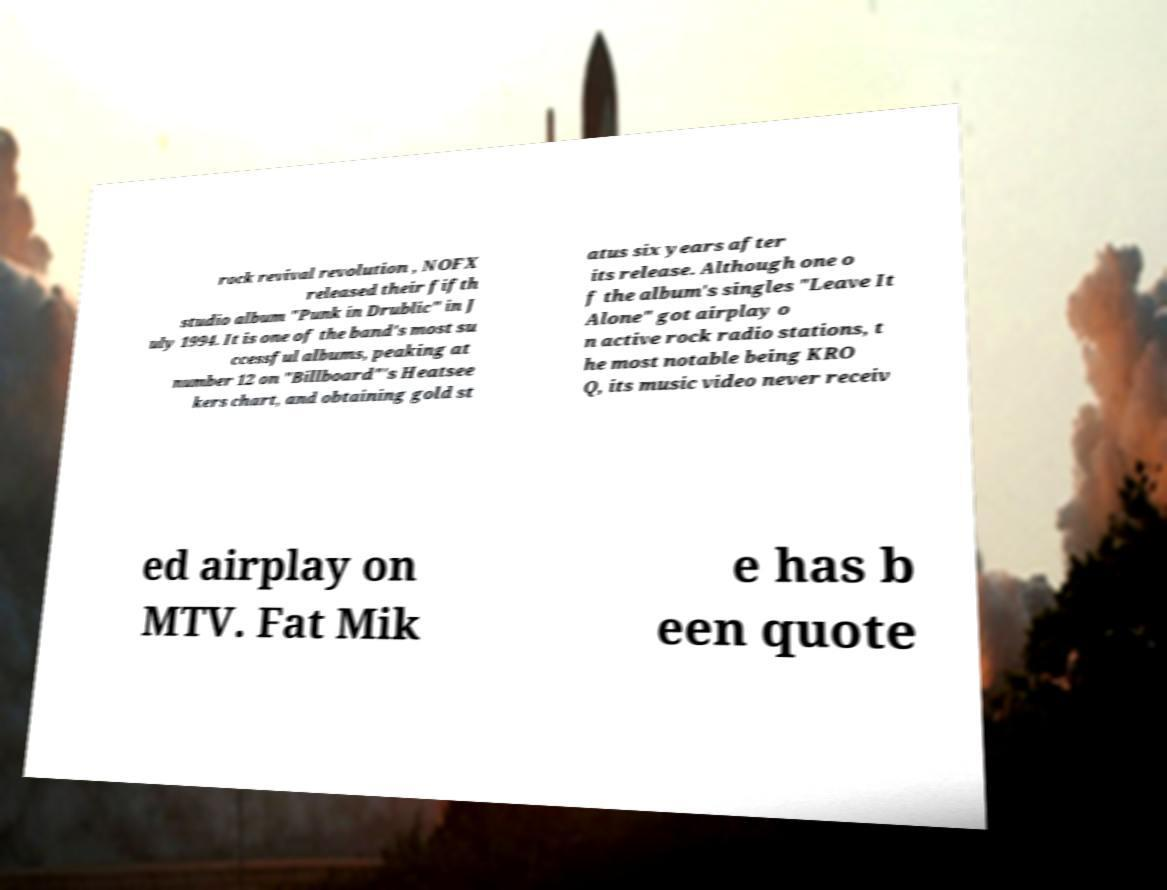Please identify and transcribe the text found in this image. rock revival revolution , NOFX released their fifth studio album "Punk in Drublic" in J uly 1994. It is one of the band's most su ccessful albums, peaking at number 12 on "Billboard"'s Heatsee kers chart, and obtaining gold st atus six years after its release. Although one o f the album's singles "Leave It Alone" got airplay o n active rock radio stations, t he most notable being KRO Q, its music video never receiv ed airplay on MTV. Fat Mik e has b een quote 